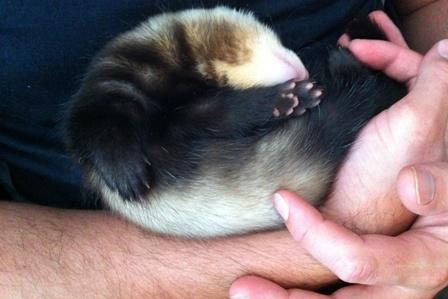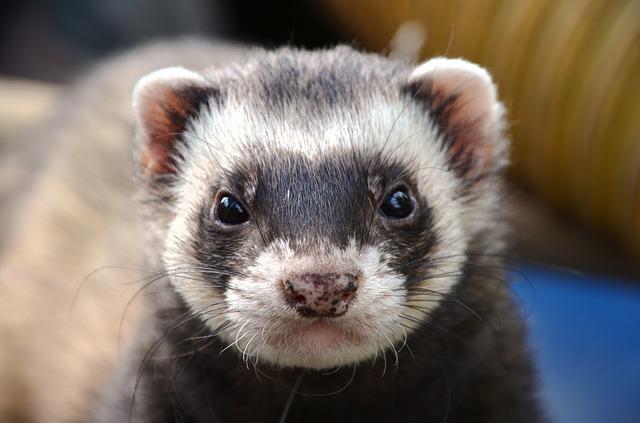The first image is the image on the left, the second image is the image on the right. For the images shown, is this caption "The right image shows just one ferret, and it has a mottled brown nose." true? Answer yes or no. Yes. 